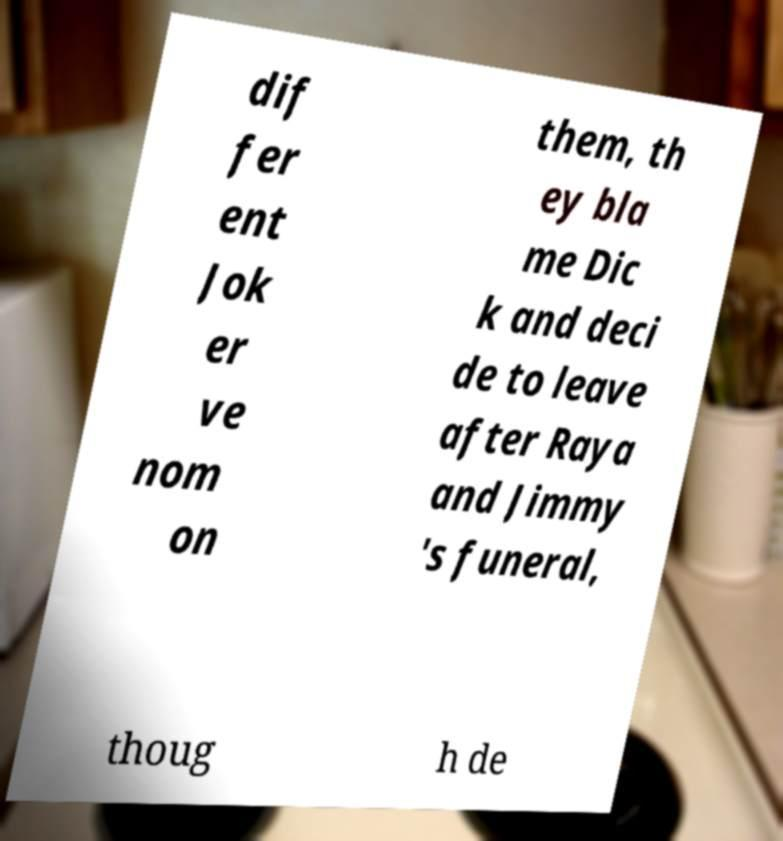I need the written content from this picture converted into text. Can you do that? dif fer ent Jok er ve nom on them, th ey bla me Dic k and deci de to leave after Raya and Jimmy 's funeral, thoug h de 